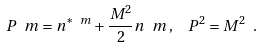Convert formula to latex. <formula><loc_0><loc_0><loc_500><loc_500>P ^ { \ } m = n ^ { * \ m } + \frac { M ^ { 2 } } { 2 } n ^ { \ } m \, , \ \ P ^ { 2 } = M ^ { 2 } \ .</formula> 